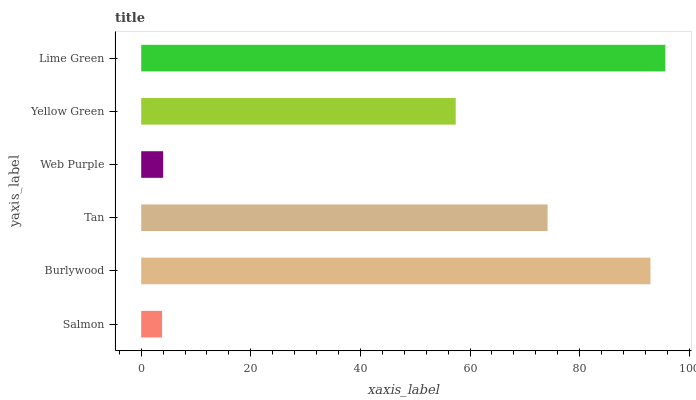Is Salmon the minimum?
Answer yes or no. Yes. Is Lime Green the maximum?
Answer yes or no. Yes. Is Burlywood the minimum?
Answer yes or no. No. Is Burlywood the maximum?
Answer yes or no. No. Is Burlywood greater than Salmon?
Answer yes or no. Yes. Is Salmon less than Burlywood?
Answer yes or no. Yes. Is Salmon greater than Burlywood?
Answer yes or no. No. Is Burlywood less than Salmon?
Answer yes or no. No. Is Tan the high median?
Answer yes or no. Yes. Is Yellow Green the low median?
Answer yes or no. Yes. Is Web Purple the high median?
Answer yes or no. No. Is Burlywood the low median?
Answer yes or no. No. 